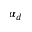<formula> <loc_0><loc_0><loc_500><loc_500>\alpha _ { d }</formula> 